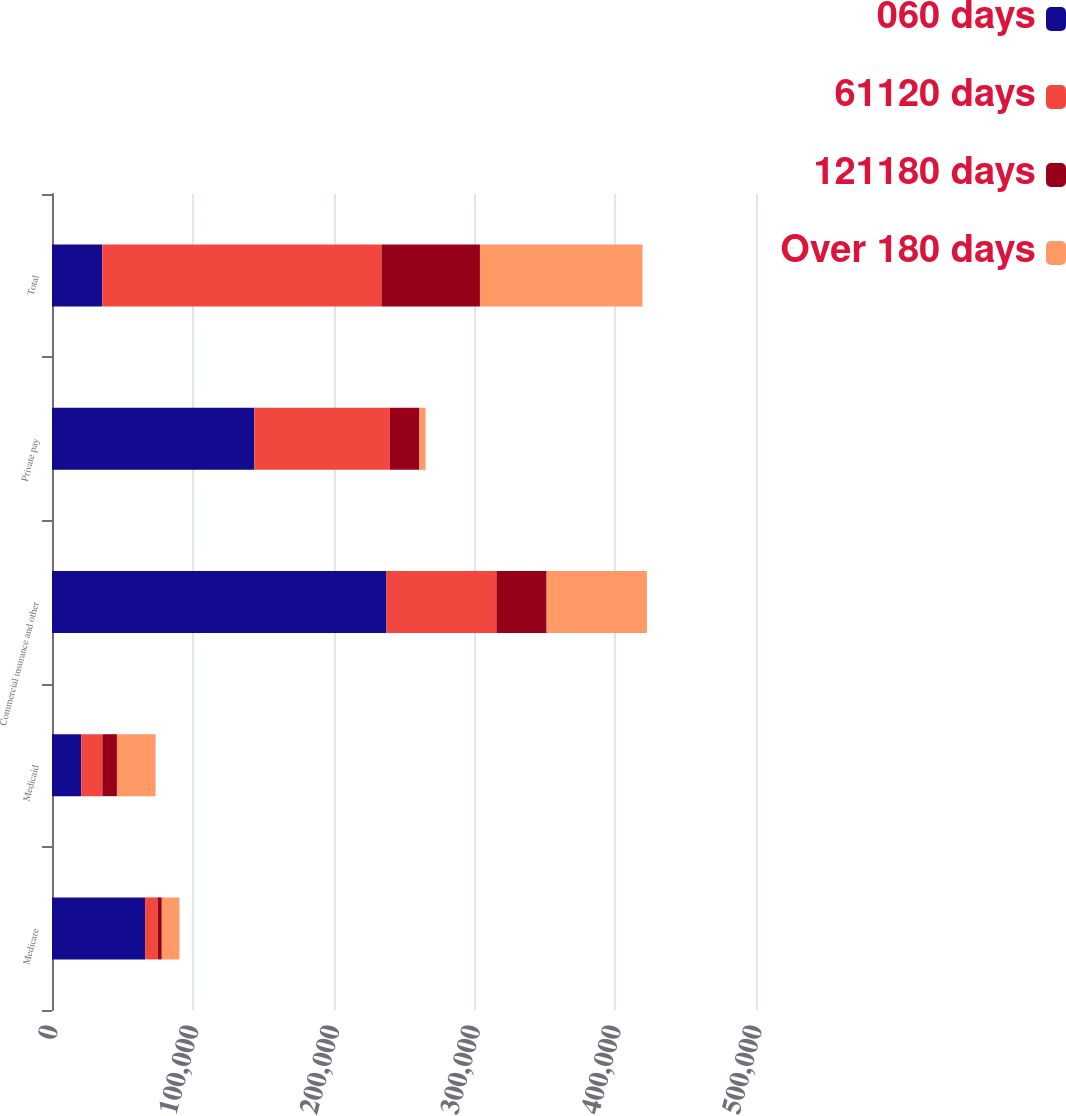<chart> <loc_0><loc_0><loc_500><loc_500><stacked_bar_chart><ecel><fcel>Medicare<fcel>Medicaid<fcel>Commercial insurance and other<fcel>Private pay<fcel>Total<nl><fcel>060 days<fcel>66125<fcel>20710<fcel>237587<fcel>143683<fcel>35671<nl><fcel>61120 days<fcel>8885<fcel>15095<fcel>78048<fcel>96294<fcel>198322<nl><fcel>121180 days<fcel>2983<fcel>10309<fcel>35671<fcel>20983<fcel>69946<nl><fcel>Over 180 days<fcel>12500<fcel>27422<fcel>71191<fcel>4354<fcel>115467<nl></chart> 